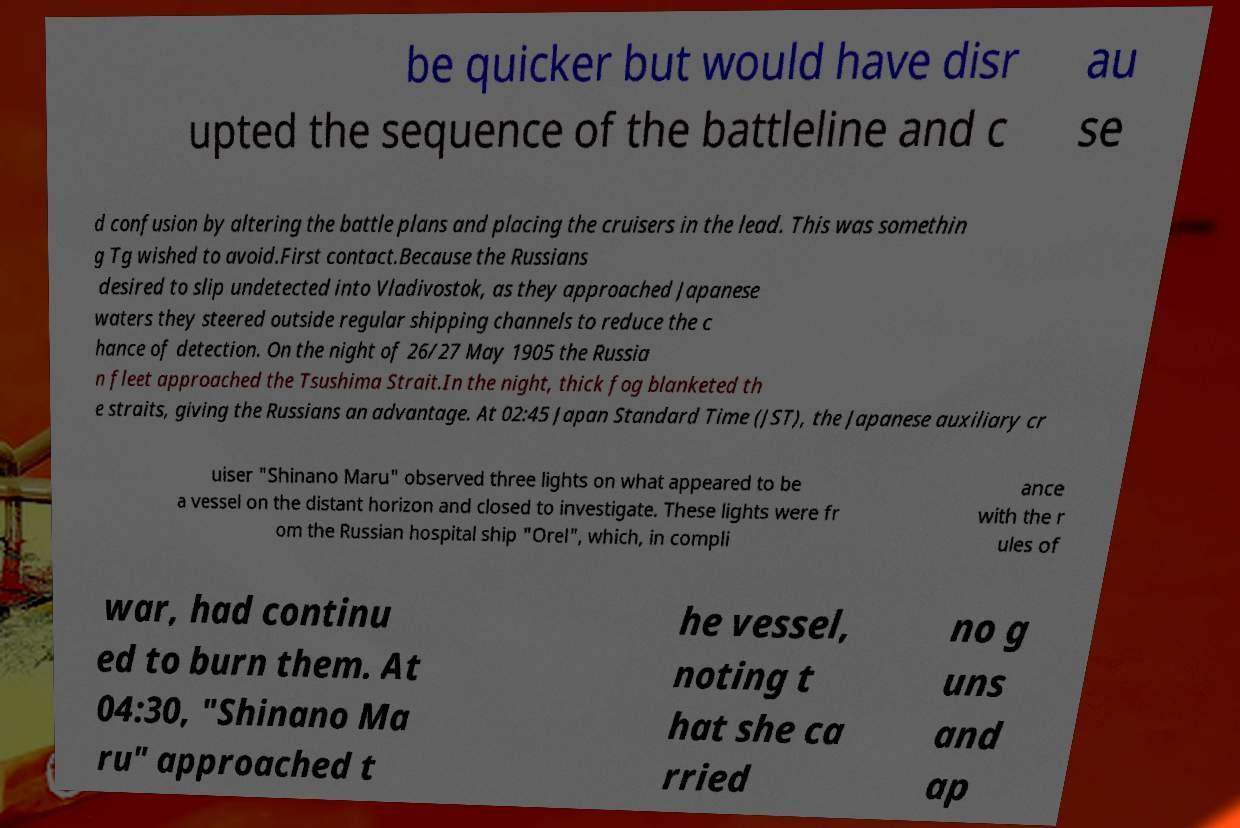Could you assist in decoding the text presented in this image and type it out clearly? be quicker but would have disr upted the sequence of the battleline and c au se d confusion by altering the battle plans and placing the cruisers in the lead. This was somethin g Tg wished to avoid.First contact.Because the Russians desired to slip undetected into Vladivostok, as they approached Japanese waters they steered outside regular shipping channels to reduce the c hance of detection. On the night of 26/27 May 1905 the Russia n fleet approached the Tsushima Strait.In the night, thick fog blanketed th e straits, giving the Russians an advantage. At 02:45 Japan Standard Time (JST), the Japanese auxiliary cr uiser "Shinano Maru" observed three lights on what appeared to be a vessel on the distant horizon and closed to investigate. These lights were fr om the Russian hospital ship "Orel", which, in compli ance with the r ules of war, had continu ed to burn them. At 04:30, "Shinano Ma ru" approached t he vessel, noting t hat she ca rried no g uns and ap 